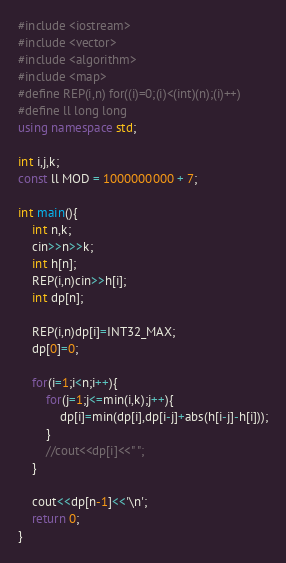<code> <loc_0><loc_0><loc_500><loc_500><_C++_>#include <iostream>
#include <vector>
#include <algorithm>
#include <map>
#define REP(i,n) for((i)=0;(i)<(int)(n);(i)++)
#define ll long long
using namespace std;

int i,j,k;
const ll MOD = 1000000000 + 7;

int main(){
    int n,k;
    cin>>n>>k;
    int h[n];
    REP(i,n)cin>>h[i];
    int dp[n];
    
    REP(i,n)dp[i]=INT32_MAX;
    dp[0]=0;

    for(i=1;i<n;i++){
        for(j=1;j<=min(i,k);j++){
            dp[i]=min(dp[i],dp[i-j]+abs(h[i-j]-h[i]));
        }
        //cout<<dp[i]<<" ";
    }

    cout<<dp[n-1]<<'\n';
    return 0;
}</code> 